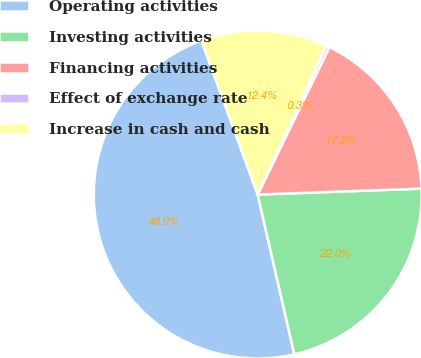<chart> <loc_0><loc_0><loc_500><loc_500><pie_chart><fcel>Operating activities<fcel>Investing activities<fcel>Financing activities<fcel>Effect of exchange rate<fcel>Increase in cash and cash<nl><fcel>48.01%<fcel>21.99%<fcel>17.22%<fcel>0.33%<fcel>12.45%<nl></chart> 